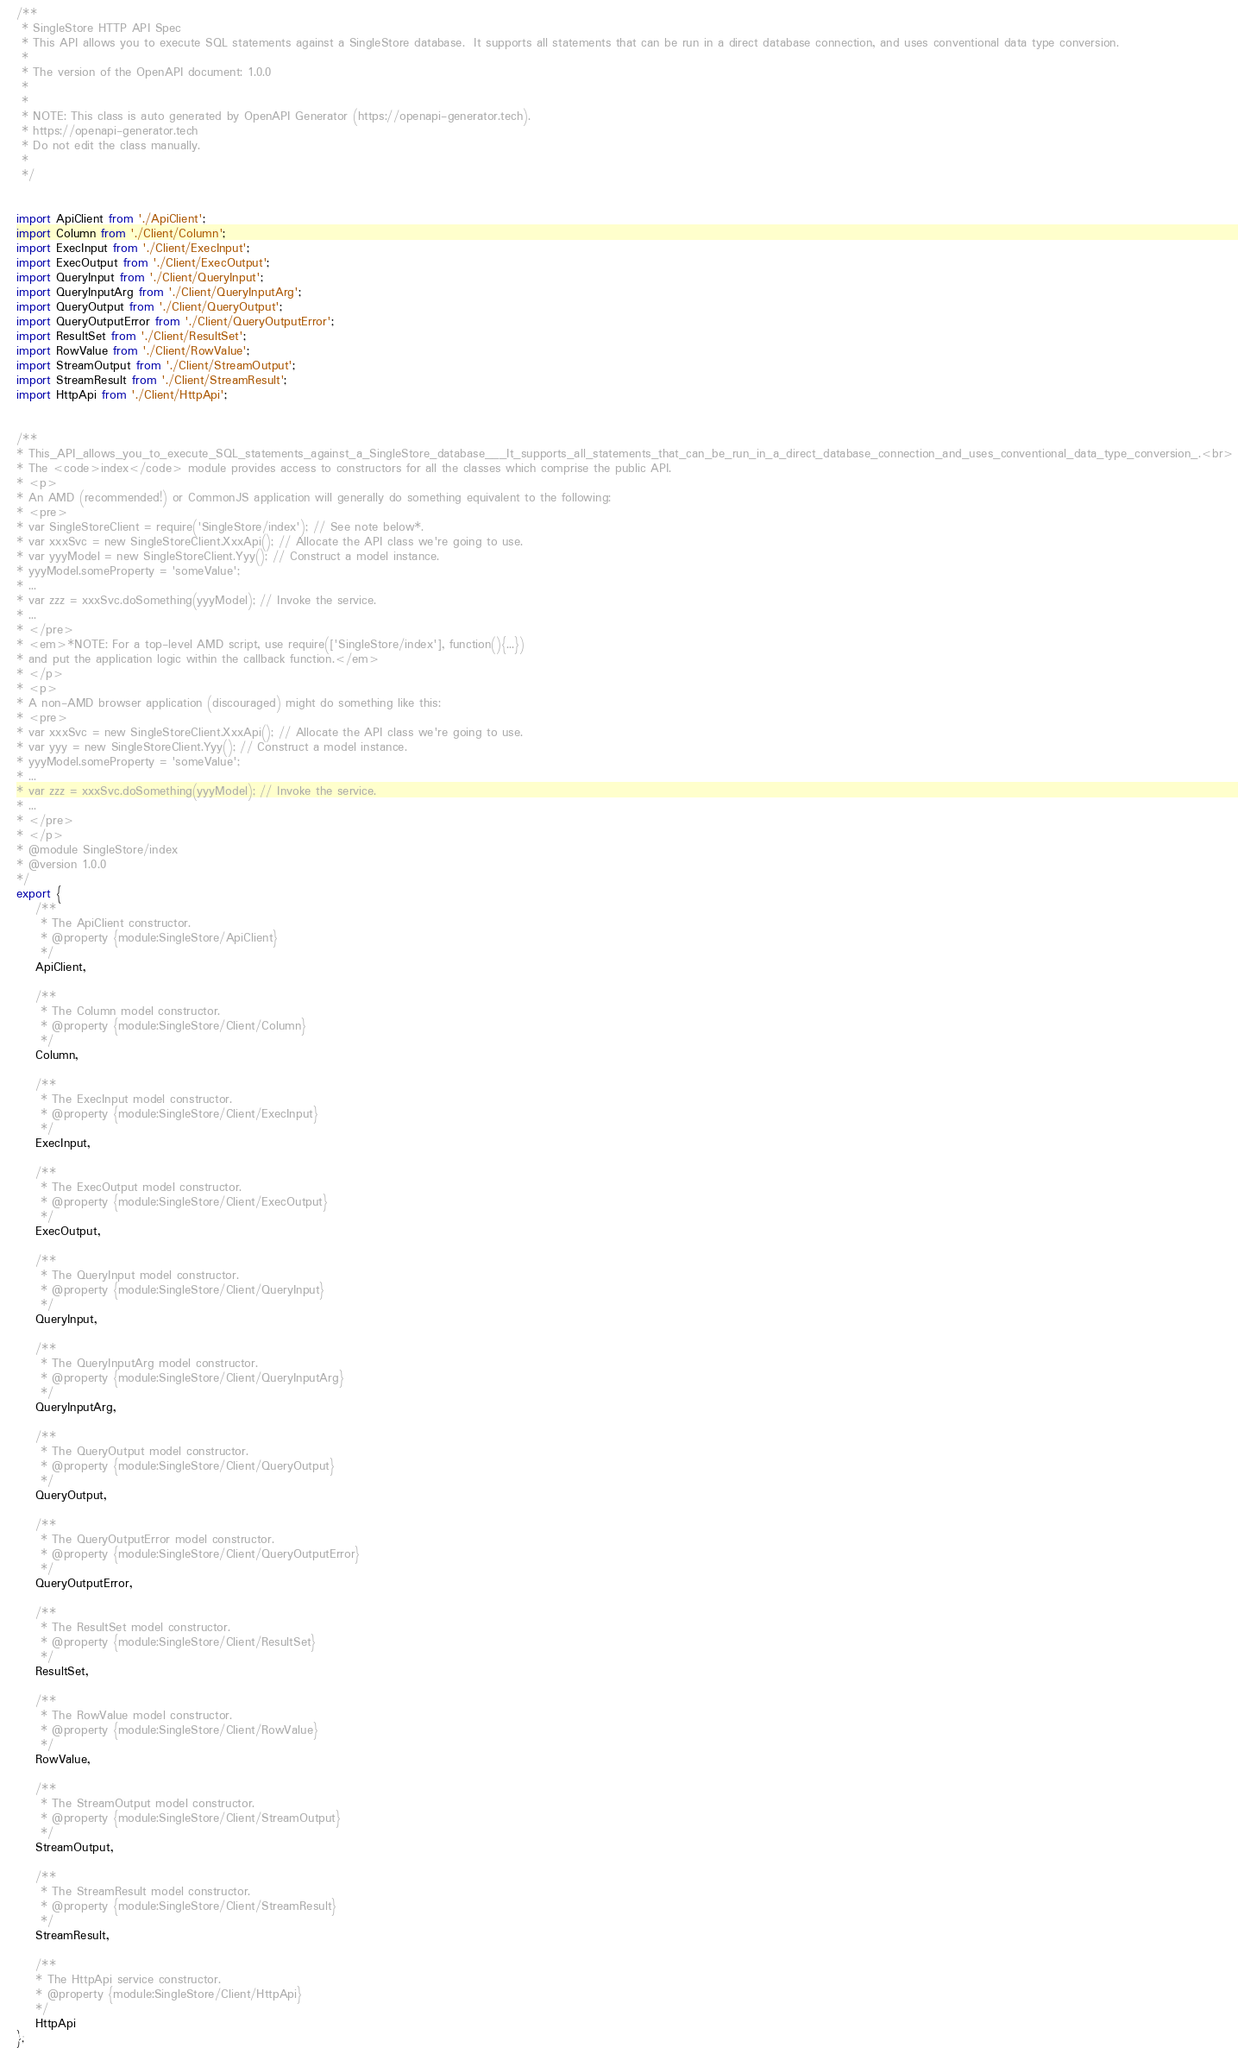Convert code to text. <code><loc_0><loc_0><loc_500><loc_500><_JavaScript_>/**
 * SingleStore HTTP API Spec
 * This API allows you to execute SQL statements against a SingleStore database.  It supports all statements that can be run in a direct database connection, and uses conventional data type conversion.
 *
 * The version of the OpenAPI document: 1.0.0
 * 
 *
 * NOTE: This class is auto generated by OpenAPI Generator (https://openapi-generator.tech).
 * https://openapi-generator.tech
 * Do not edit the class manually.
 *
 */


import ApiClient from './ApiClient';
import Column from './Client/Column';
import ExecInput from './Client/ExecInput';
import ExecOutput from './Client/ExecOutput';
import QueryInput from './Client/QueryInput';
import QueryInputArg from './Client/QueryInputArg';
import QueryOutput from './Client/QueryOutput';
import QueryOutputError from './Client/QueryOutputError';
import ResultSet from './Client/ResultSet';
import RowValue from './Client/RowValue';
import StreamOutput from './Client/StreamOutput';
import StreamResult from './Client/StreamResult';
import HttpApi from './Client/HttpApi';


/**
* This_API_allows_you_to_execute_SQL_statements_against_a_SingleStore_database___It_supports_all_statements_that_can_be_run_in_a_direct_database_connection_and_uses_conventional_data_type_conversion_.<br>
* The <code>index</code> module provides access to constructors for all the classes which comprise the public API.
* <p>
* An AMD (recommended!) or CommonJS application will generally do something equivalent to the following:
* <pre>
* var SingleStoreClient = require('SingleStore/index'); // See note below*.
* var xxxSvc = new SingleStoreClient.XxxApi(); // Allocate the API class we're going to use.
* var yyyModel = new SingleStoreClient.Yyy(); // Construct a model instance.
* yyyModel.someProperty = 'someValue';
* ...
* var zzz = xxxSvc.doSomething(yyyModel); // Invoke the service.
* ...
* </pre>
* <em>*NOTE: For a top-level AMD script, use require(['SingleStore/index'], function(){...})
* and put the application logic within the callback function.</em>
* </p>
* <p>
* A non-AMD browser application (discouraged) might do something like this:
* <pre>
* var xxxSvc = new SingleStoreClient.XxxApi(); // Allocate the API class we're going to use.
* var yyy = new SingleStoreClient.Yyy(); // Construct a model instance.
* yyyModel.someProperty = 'someValue';
* ...
* var zzz = xxxSvc.doSomething(yyyModel); // Invoke the service.
* ...
* </pre>
* </p>
* @module SingleStore/index
* @version 1.0.0
*/
export {
    /**
     * The ApiClient constructor.
     * @property {module:SingleStore/ApiClient}
     */
    ApiClient,

    /**
     * The Column model constructor.
     * @property {module:SingleStore/Client/Column}
     */
    Column,

    /**
     * The ExecInput model constructor.
     * @property {module:SingleStore/Client/ExecInput}
     */
    ExecInput,

    /**
     * The ExecOutput model constructor.
     * @property {module:SingleStore/Client/ExecOutput}
     */
    ExecOutput,

    /**
     * The QueryInput model constructor.
     * @property {module:SingleStore/Client/QueryInput}
     */
    QueryInput,

    /**
     * The QueryInputArg model constructor.
     * @property {module:SingleStore/Client/QueryInputArg}
     */
    QueryInputArg,

    /**
     * The QueryOutput model constructor.
     * @property {module:SingleStore/Client/QueryOutput}
     */
    QueryOutput,

    /**
     * The QueryOutputError model constructor.
     * @property {module:SingleStore/Client/QueryOutputError}
     */
    QueryOutputError,

    /**
     * The ResultSet model constructor.
     * @property {module:SingleStore/Client/ResultSet}
     */
    ResultSet,

    /**
     * The RowValue model constructor.
     * @property {module:SingleStore/Client/RowValue}
     */
    RowValue,

    /**
     * The StreamOutput model constructor.
     * @property {module:SingleStore/Client/StreamOutput}
     */
    StreamOutput,

    /**
     * The StreamResult model constructor.
     * @property {module:SingleStore/Client/StreamResult}
     */
    StreamResult,

    /**
    * The HttpApi service constructor.
    * @property {module:SingleStore/Client/HttpApi}
    */
    HttpApi
};
</code> 